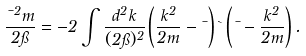Convert formula to latex. <formula><loc_0><loc_0><loc_500><loc_500>\frac { \mu ^ { 2 } m } { 2 \pi } = - 2 \int \frac { d ^ { 2 } k } { ( 2 \pi ) ^ { 2 } } \left ( \frac { k ^ { 2 } } { 2 m } - \mu \right ) \theta \left ( \mu - \frac { k ^ { 2 } } { 2 m } \right ) .</formula> 